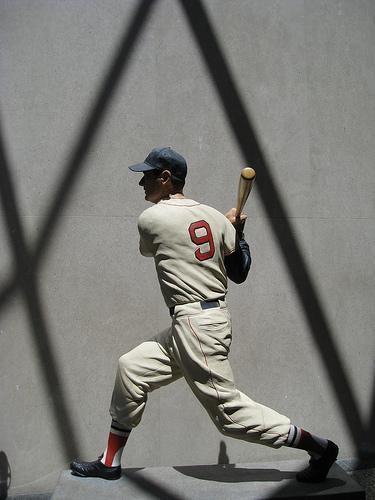How many bats are there?
Give a very brief answer. 1. 